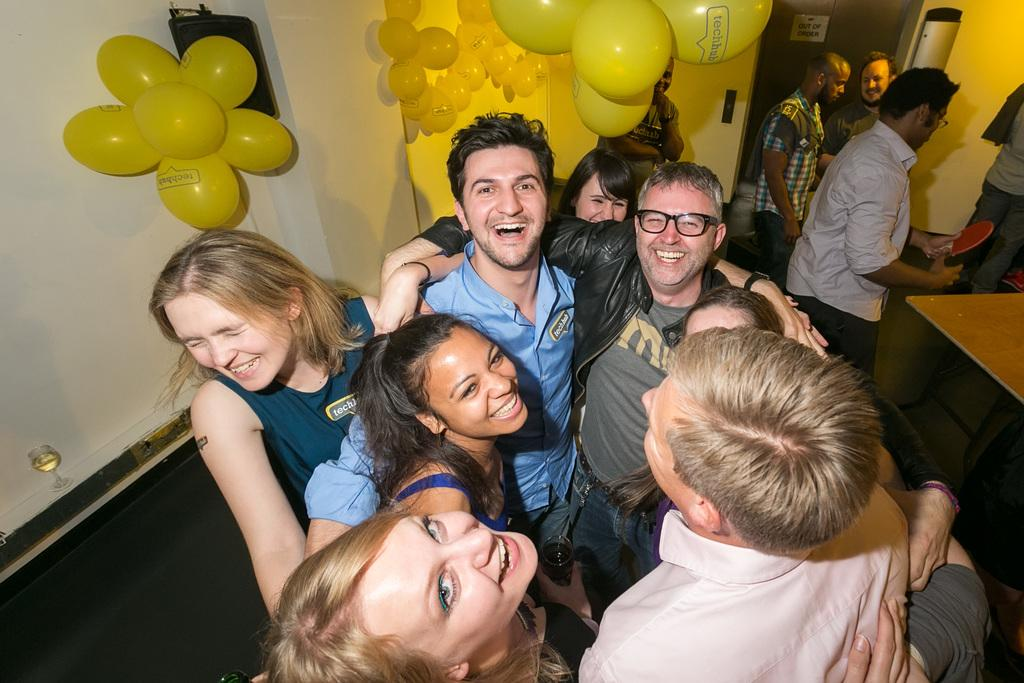What is happening in the foreground of the image? There is a group of people on the floor in the foreground of the image. What is located near the group of people? There is a table in the foreground of the image. What can be seen on the wall in the background of the image? There are balloons on a wall in the background of the image. What architectural feature is visible in the background of the image? There is a door in the background of the image. What type of location might the image have been taken in? The image may have been taken in a hall. What time of day is the cast performing in the image? There is no cast performing in the image, and therefore no specific time of day can be determined. What type of stranger can be seen interacting with the group of people in the image? There is no stranger present in the image; only a group of people and a table are visible. 